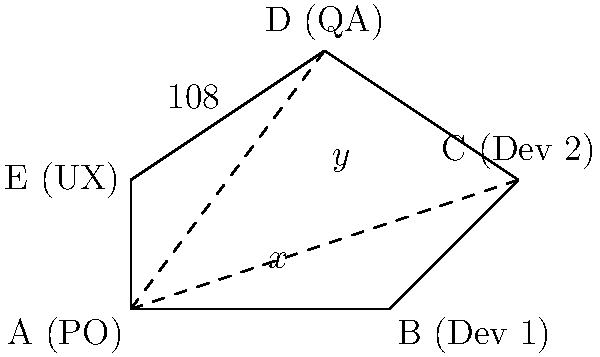In a product development team represented by a pentagon ABCDE, where each vertex represents a different role (A: Product Owner, B: Developer 1, C: Developer 2, D: QA, E: UX), the internal angle at D (QA) is 108°. If x° represents the angle CAB and y° represents the angle DAC, what is the value of x + y? Let's approach this step-by-step:

1) In a pentagon, the sum of all internal angles is $(5-2) \times 180° = 540°$.

2) We're given that angle D is 108°. Let's call the other angles:
   $\angle A = a°$, $\angle B = b°$, $\angle C = c°$, $\angle E = e°$

3) We can write the equation: $a + b + c + 108 + e = 540$

4) In the triangle ACD:
   $x + y + 108 = 180$ (sum of angles in a triangle)
   $x + y = 72$

5) Also in triangle ACD:
   $x + y + (180 - a) = 180$ (the angle at A in this triangle is the external angle of the pentagon)
   $x + y = a$

6) From steps 4 and 5, we can conclude: $a = 72°$

7) Due to the symmetry of a regular pentagon, all angles should be equal. Even though it's not explicitly stated that this is a regular pentagon, the fact that one angle is 108° (which is the measure of each angle in a regular pentagon) suggests that all angles are likely 108°.

8) If all angles are 108°, then $x + y = 72°$ as we found in step 4.

Therefore, the value of $x + y$ is 72°.
Answer: 72° 